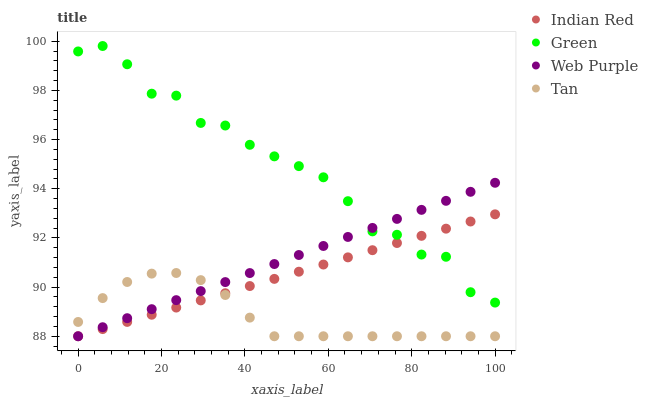Does Tan have the minimum area under the curve?
Answer yes or no. Yes. Does Green have the maximum area under the curve?
Answer yes or no. Yes. Does Green have the minimum area under the curve?
Answer yes or no. No. Does Tan have the maximum area under the curve?
Answer yes or no. No. Is Web Purple the smoothest?
Answer yes or no. Yes. Is Green the roughest?
Answer yes or no. Yes. Is Tan the smoothest?
Answer yes or no. No. Is Tan the roughest?
Answer yes or no. No. Does Web Purple have the lowest value?
Answer yes or no. Yes. Does Green have the lowest value?
Answer yes or no. No. Does Green have the highest value?
Answer yes or no. Yes. Does Tan have the highest value?
Answer yes or no. No. Is Tan less than Green?
Answer yes or no. Yes. Is Green greater than Tan?
Answer yes or no. Yes. Does Tan intersect Web Purple?
Answer yes or no. Yes. Is Tan less than Web Purple?
Answer yes or no. No. Is Tan greater than Web Purple?
Answer yes or no. No. Does Tan intersect Green?
Answer yes or no. No. 